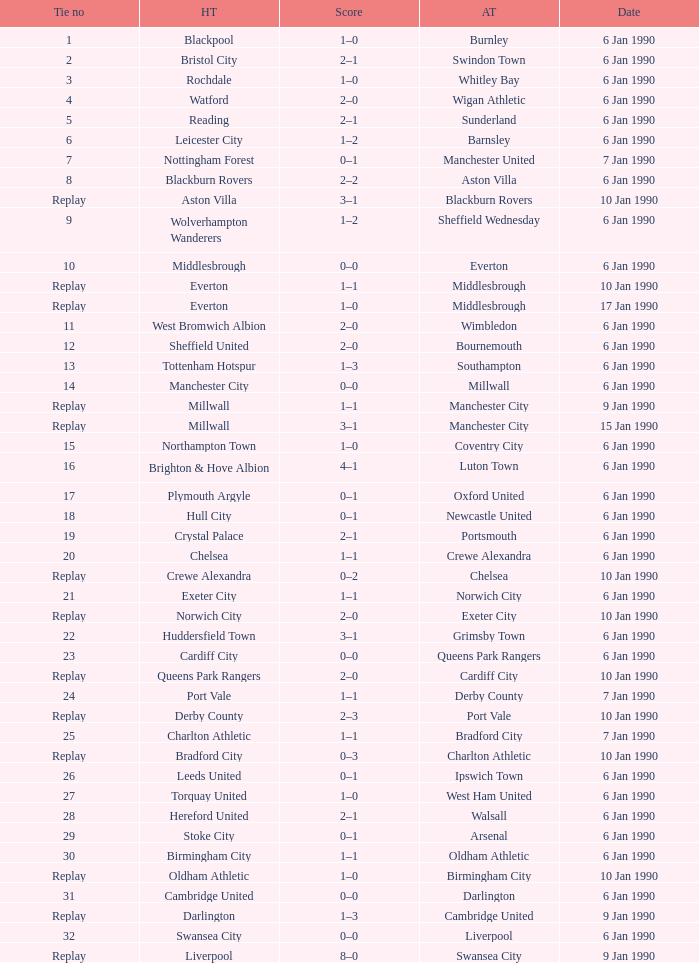Give me the full table as a dictionary. {'header': ['Tie no', 'HT', 'Score', 'AT', 'Date'], 'rows': [['1', 'Blackpool', '1–0', 'Burnley', '6 Jan 1990'], ['2', 'Bristol City', '2–1', 'Swindon Town', '6 Jan 1990'], ['3', 'Rochdale', '1–0', 'Whitley Bay', '6 Jan 1990'], ['4', 'Watford', '2–0', 'Wigan Athletic', '6 Jan 1990'], ['5', 'Reading', '2–1', 'Sunderland', '6 Jan 1990'], ['6', 'Leicester City', '1–2', 'Barnsley', '6 Jan 1990'], ['7', 'Nottingham Forest', '0–1', 'Manchester United', '7 Jan 1990'], ['8', 'Blackburn Rovers', '2–2', 'Aston Villa', '6 Jan 1990'], ['Replay', 'Aston Villa', '3–1', 'Blackburn Rovers', '10 Jan 1990'], ['9', 'Wolverhampton Wanderers', '1–2', 'Sheffield Wednesday', '6 Jan 1990'], ['10', 'Middlesbrough', '0–0', 'Everton', '6 Jan 1990'], ['Replay', 'Everton', '1–1', 'Middlesbrough', '10 Jan 1990'], ['Replay', 'Everton', '1–0', 'Middlesbrough', '17 Jan 1990'], ['11', 'West Bromwich Albion', '2–0', 'Wimbledon', '6 Jan 1990'], ['12', 'Sheffield United', '2–0', 'Bournemouth', '6 Jan 1990'], ['13', 'Tottenham Hotspur', '1–3', 'Southampton', '6 Jan 1990'], ['14', 'Manchester City', '0–0', 'Millwall', '6 Jan 1990'], ['Replay', 'Millwall', '1–1', 'Manchester City', '9 Jan 1990'], ['Replay', 'Millwall', '3–1', 'Manchester City', '15 Jan 1990'], ['15', 'Northampton Town', '1–0', 'Coventry City', '6 Jan 1990'], ['16', 'Brighton & Hove Albion', '4–1', 'Luton Town', '6 Jan 1990'], ['17', 'Plymouth Argyle', '0–1', 'Oxford United', '6 Jan 1990'], ['18', 'Hull City', '0–1', 'Newcastle United', '6 Jan 1990'], ['19', 'Crystal Palace', '2–1', 'Portsmouth', '6 Jan 1990'], ['20', 'Chelsea', '1–1', 'Crewe Alexandra', '6 Jan 1990'], ['Replay', 'Crewe Alexandra', '0–2', 'Chelsea', '10 Jan 1990'], ['21', 'Exeter City', '1–1', 'Norwich City', '6 Jan 1990'], ['Replay', 'Norwich City', '2–0', 'Exeter City', '10 Jan 1990'], ['22', 'Huddersfield Town', '3–1', 'Grimsby Town', '6 Jan 1990'], ['23', 'Cardiff City', '0–0', 'Queens Park Rangers', '6 Jan 1990'], ['Replay', 'Queens Park Rangers', '2–0', 'Cardiff City', '10 Jan 1990'], ['24', 'Port Vale', '1–1', 'Derby County', '7 Jan 1990'], ['Replay', 'Derby County', '2–3', 'Port Vale', '10 Jan 1990'], ['25', 'Charlton Athletic', '1–1', 'Bradford City', '7 Jan 1990'], ['Replay', 'Bradford City', '0–3', 'Charlton Athletic', '10 Jan 1990'], ['26', 'Leeds United', '0–1', 'Ipswich Town', '6 Jan 1990'], ['27', 'Torquay United', '1–0', 'West Ham United', '6 Jan 1990'], ['28', 'Hereford United', '2–1', 'Walsall', '6 Jan 1990'], ['29', 'Stoke City', '0–1', 'Arsenal', '6 Jan 1990'], ['30', 'Birmingham City', '1–1', 'Oldham Athletic', '6 Jan 1990'], ['Replay', 'Oldham Athletic', '1–0', 'Birmingham City', '10 Jan 1990'], ['31', 'Cambridge United', '0–0', 'Darlington', '6 Jan 1990'], ['Replay', 'Darlington', '1–3', 'Cambridge United', '9 Jan 1990'], ['32', 'Swansea City', '0–0', 'Liverpool', '6 Jan 1990'], ['Replay', 'Liverpool', '8–0', 'Swansea City', '9 Jan 1990']]} What was the score of the game against away team crewe alexandra? 1–1. 